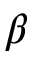<formula> <loc_0><loc_0><loc_500><loc_500>\beta</formula> 